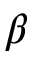<formula> <loc_0><loc_0><loc_500><loc_500>\beta</formula> 